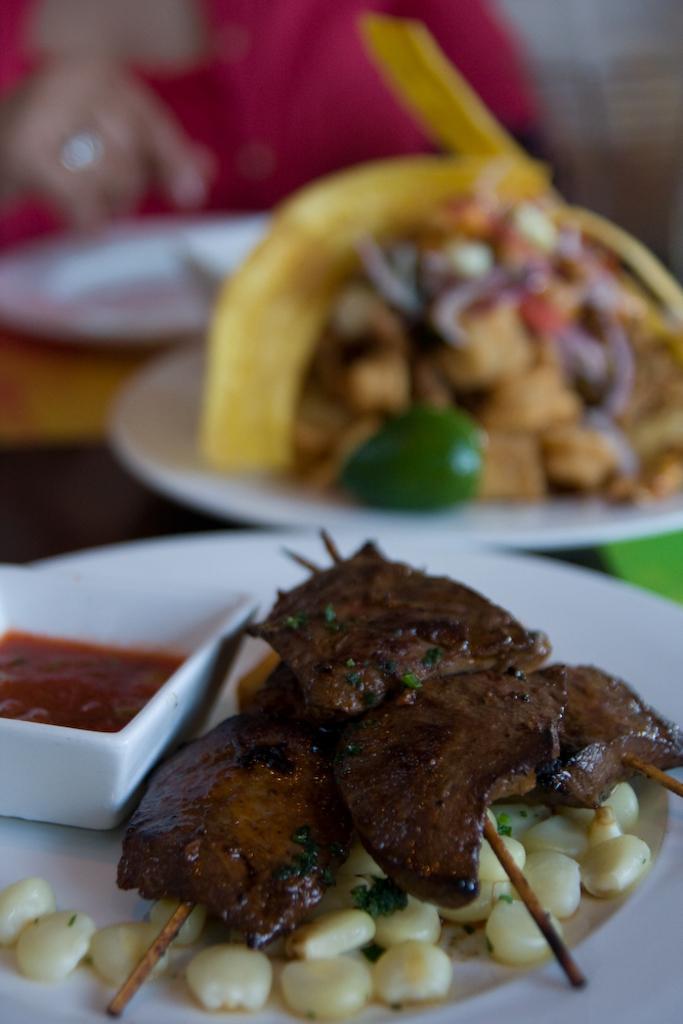Could you give a brief overview of what you see in this image? In this picture we can see plates, bowl, and food on a platform. In the background we can see a person. 